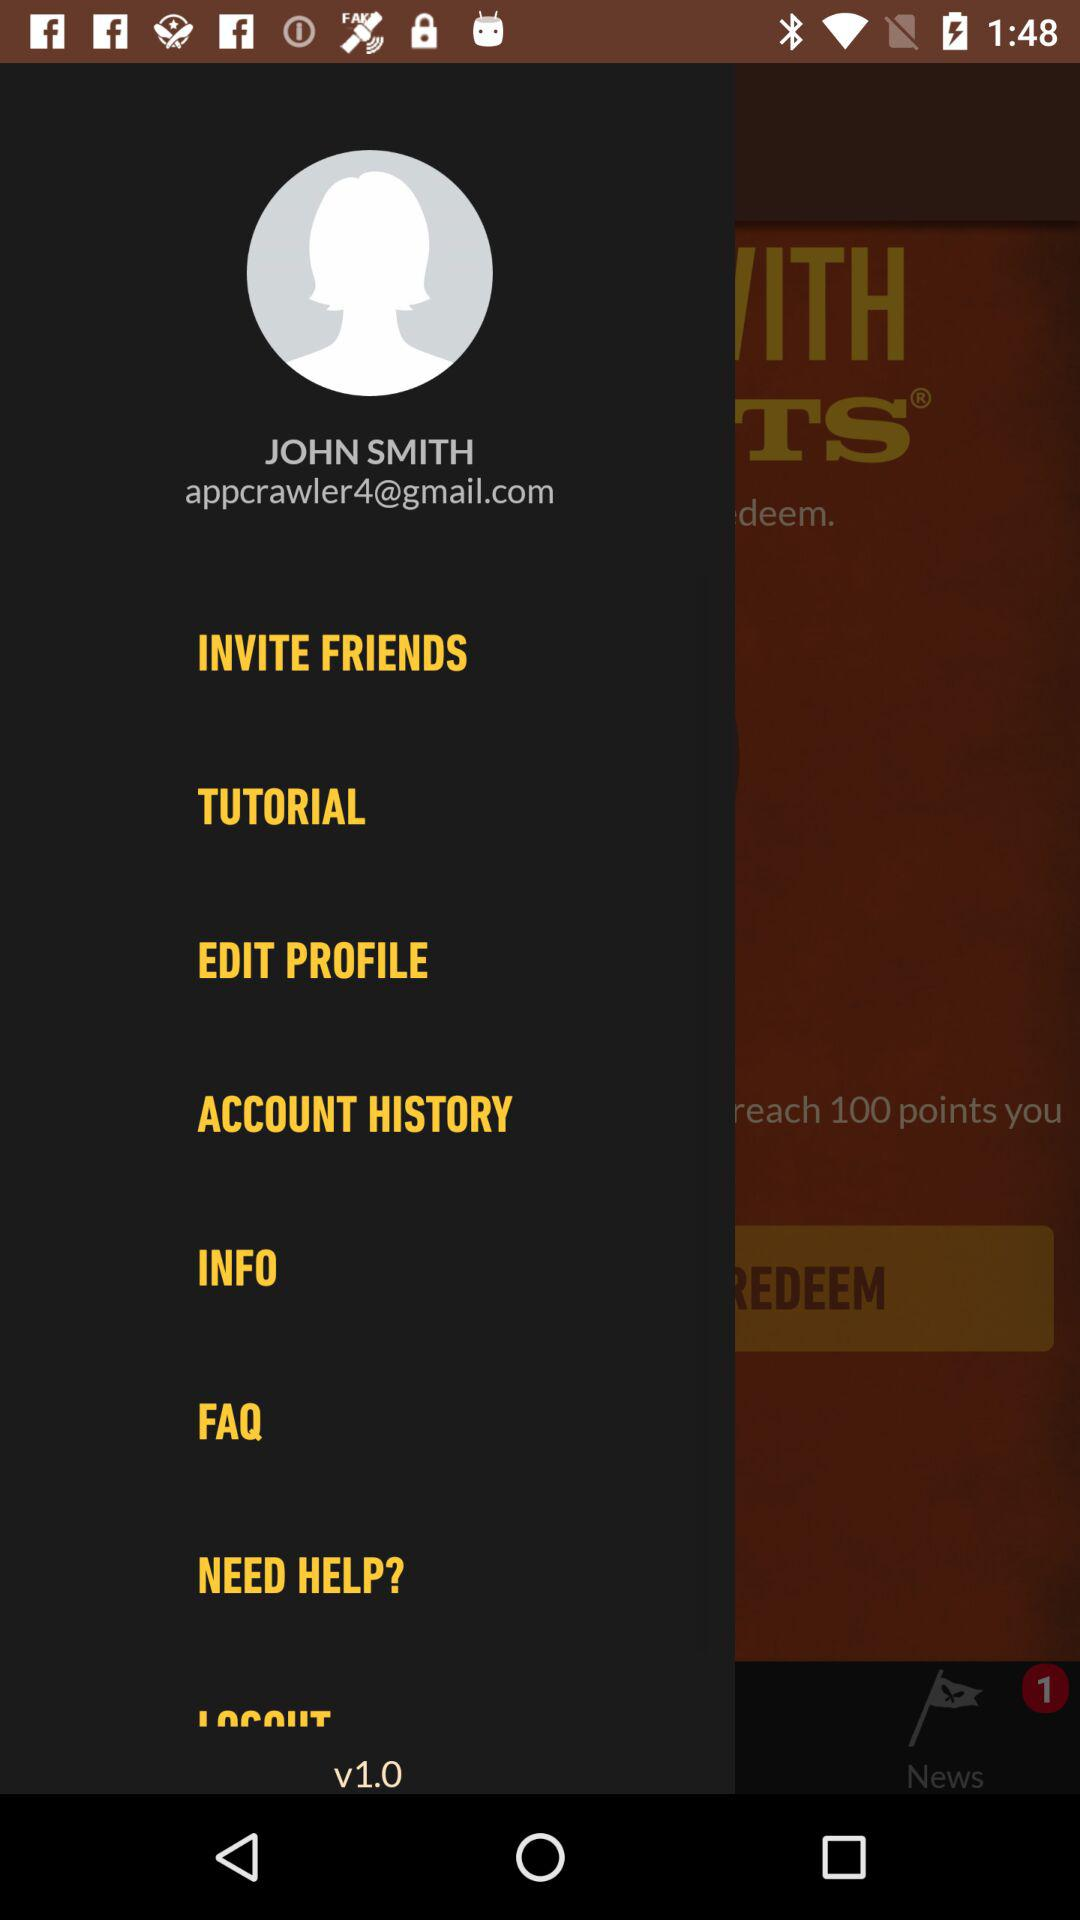What is the user name? The user name is John Smith. 